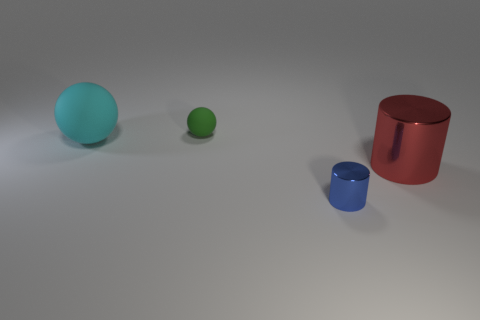What can you tell me about the scale or size of these objects? The size of the objects seems to follow a relative scale with the larger red cylinder being the tallest object, followed by the cyan sphere, while the small blue cylinder and the tiny green matte sphere are the smallest. Comparing their sizes, could these objects serve any practical function? While their scale suggests they could represent real-world objects like containers or balls, without any additional context or features like openings or handles, their functionality remains purely speculative in this image. 